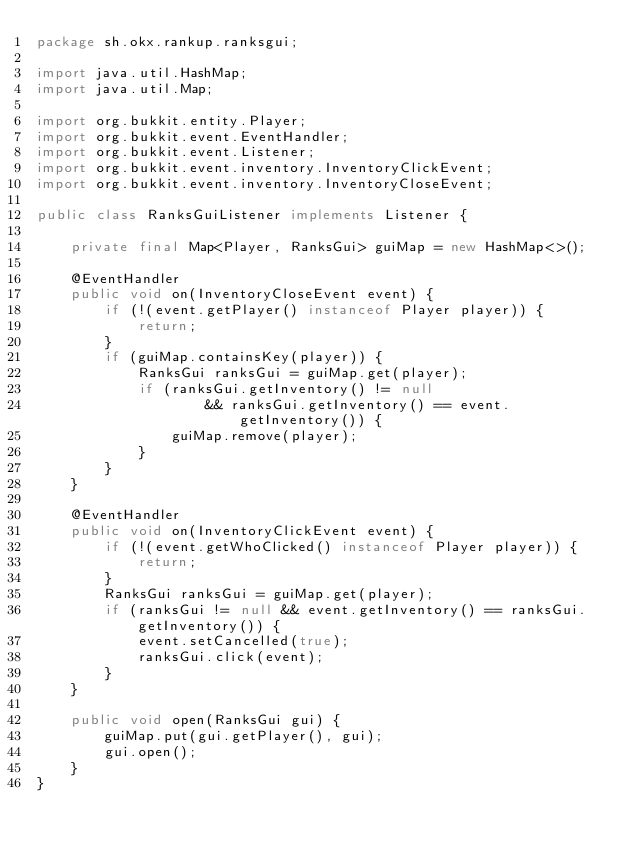<code> <loc_0><loc_0><loc_500><loc_500><_Java_>package sh.okx.rankup.ranksgui;

import java.util.HashMap;
import java.util.Map;

import org.bukkit.entity.Player;
import org.bukkit.event.EventHandler;
import org.bukkit.event.Listener;
import org.bukkit.event.inventory.InventoryClickEvent;
import org.bukkit.event.inventory.InventoryCloseEvent;

public class RanksGuiListener implements Listener {

    private final Map<Player, RanksGui> guiMap = new HashMap<>();

    @EventHandler
    public void on(InventoryCloseEvent event) {
        if (!(event.getPlayer() instanceof Player player)) {
            return;
        }
        if (guiMap.containsKey(player)) {
            RanksGui ranksGui = guiMap.get(player);
            if (ranksGui.getInventory() != null
                    && ranksGui.getInventory() == event.getInventory()) {
                guiMap.remove(player);
            }
        }
    }

    @EventHandler
    public void on(InventoryClickEvent event) {
        if (!(event.getWhoClicked() instanceof Player player)) {
            return;
        }
        RanksGui ranksGui = guiMap.get(player);
        if (ranksGui != null && event.getInventory() == ranksGui.getInventory()) {
            event.setCancelled(true);
            ranksGui.click(event);
        }
    }

    public void open(RanksGui gui) {
        guiMap.put(gui.getPlayer(), gui);
        gui.open();
    }
}
    </code> 